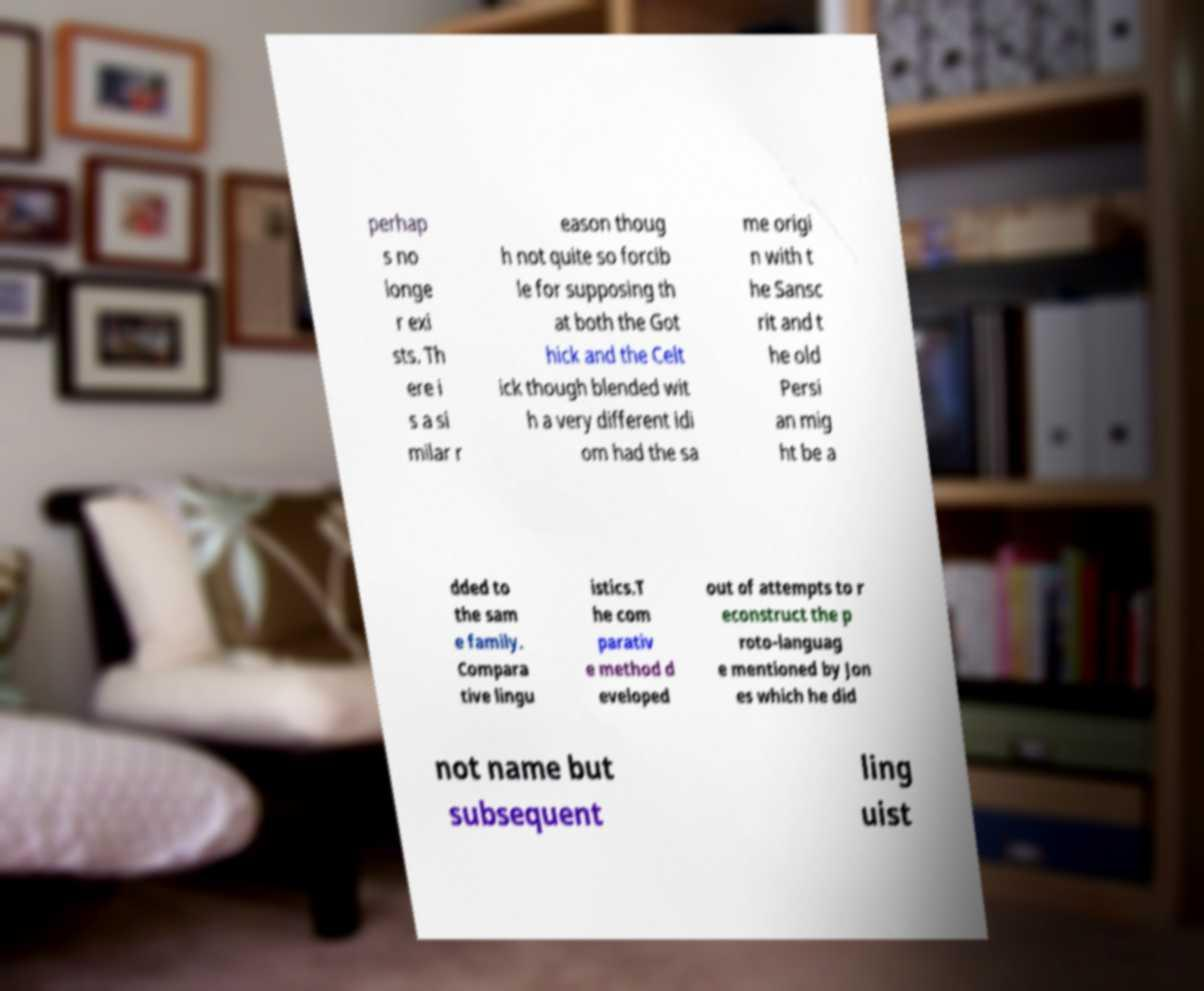Could you extract and type out the text from this image? perhap s no longe r exi sts. Th ere i s a si milar r eason thoug h not quite so forcib le for supposing th at both the Got hick and the Celt ick though blended wit h a very different idi om had the sa me origi n with t he Sansc rit and t he old Persi an mig ht be a dded to the sam e family. Compara tive lingu istics.T he com parativ e method d eveloped out of attempts to r econstruct the p roto-languag e mentioned by Jon es which he did not name but subsequent ling uist 